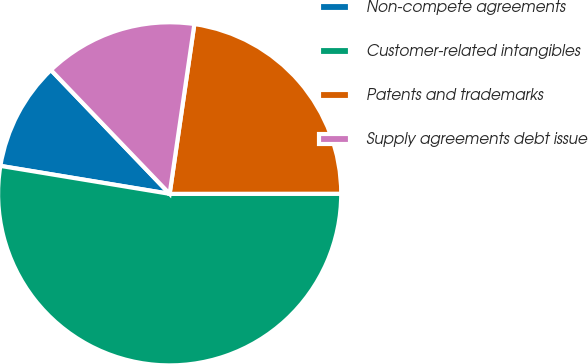Convert chart. <chart><loc_0><loc_0><loc_500><loc_500><pie_chart><fcel>Non-compete agreements<fcel>Customer-related intangibles<fcel>Patents and trademarks<fcel>Supply agreements debt issue<nl><fcel>10.23%<fcel>52.62%<fcel>22.69%<fcel>14.47%<nl></chart> 